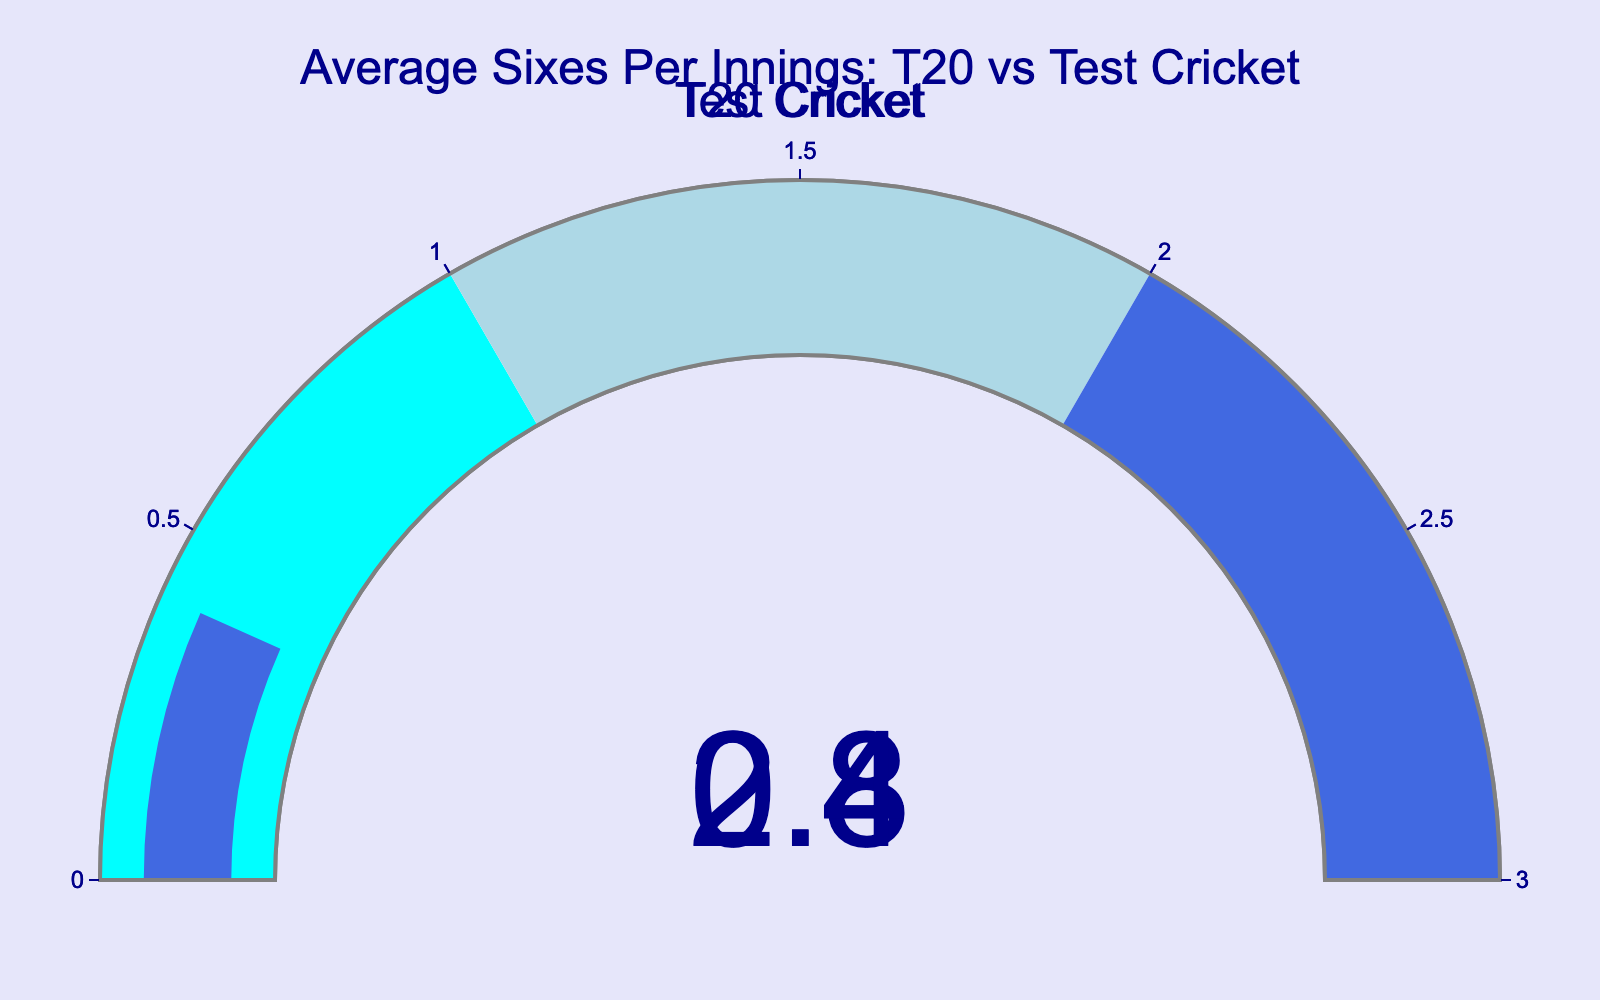What's the title of the figure? The title of a gauge chart is usually placed at the top of the figure. For this particular figure, it is located in the top center of the chart.
Answer: Average Sixes Per Innings: T20 vs Test Cricket How many gauge charts are in the figure? By visually inspecting, you will notice that the figure contains two separate gauge charts, one for each cricket format.
Answer: 2 What is the average number of sixes hit per innings in Test cricket? The gauge chart provides a numerical indicator for the average number of sixes hit per innings in Test cricket. The value shown is 0.4.
Answer: 0.4 How does the average number of sixes hit per innings in T20 cricket compare to Test cricket? By comparing the numbers displayed on the gauge charts, the average number of sixes hit per innings in T20 cricket (2.8) is significantly higher than in Test cricket (0.4).
Answer: T20 cricket has a higher average Calculate the difference in average sixes per innings between T20 and Test cricket. Subtract the average number of sixes hit per innings in Test cricket (0.4) from that in T20 cricket (2.8): 2.8 - 0.4 = 2.4.
Answer: 2.4 Which cricket format has a lower average number of sixes per innings? By examining the values on the gauge charts, Test cricket has a lower average (0.4) compared to T20 cricket (2.8).
Answer: Test cricket Is the average number of sixes per innings in Test cricket closer to 0 or 1? The gauge chart for Test cricket displays an average of 0.4, which is closer to 0 than to 1.
Answer: Closer to 0 What color represents the range 2-3 on the T20 cricket gauge chart? Observing the segmented colors on the gauge, the range of 2-3 is colored in royal blue.
Answer: Royal blue Between which two numbers is the average sixes per innings in T20 cricket range-wise displayed on the gauge? The gauge shows the average number of sixes as 2.8, which falls between 2 and 3 on the dial.
Answer: Between 2 and 3 Is the difference in average sixes per innings between the two formats closer to 2 or 3? The numerical difference calculated earlier is 2.4, which is mathematically closer to 2.
Answer: Closer to 2 